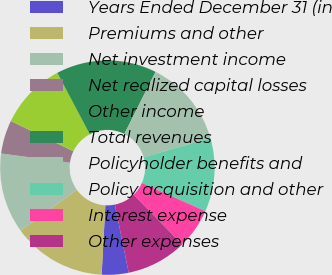Convert chart to OTSL. <chart><loc_0><loc_0><loc_500><loc_500><pie_chart><fcel>Years Ended December 31 (in<fcel>Premiums and other<fcel>Net investment income<fcel>Net realized capital losses<fcel>Other income<fcel>Total revenues<fcel>Policyholder benefits and<fcel>Policy acquisition and other<fcel>Interest expense<fcel>Other expenses<nl><fcel>4.04%<fcel>14.14%<fcel>12.12%<fcel>5.05%<fcel>10.1%<fcel>15.15%<fcel>13.13%<fcel>11.11%<fcel>6.06%<fcel>9.09%<nl></chart> 